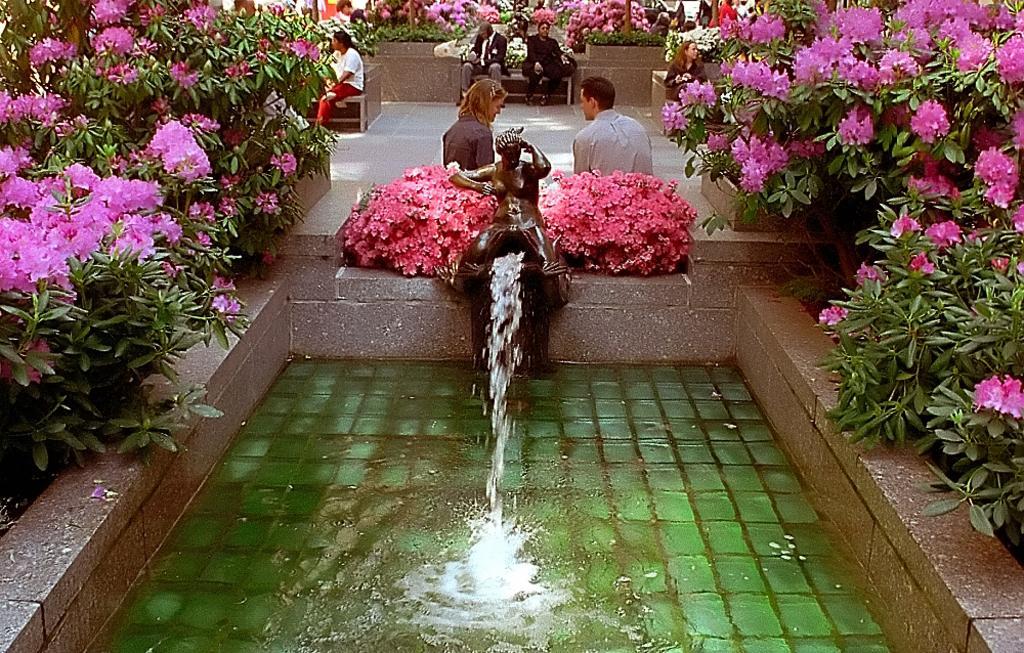Can you describe this image briefly? In this image in the front there is water. In the background there are flowers and there are persons sitting and in the center there is a statue and there is water coming from the statue. 